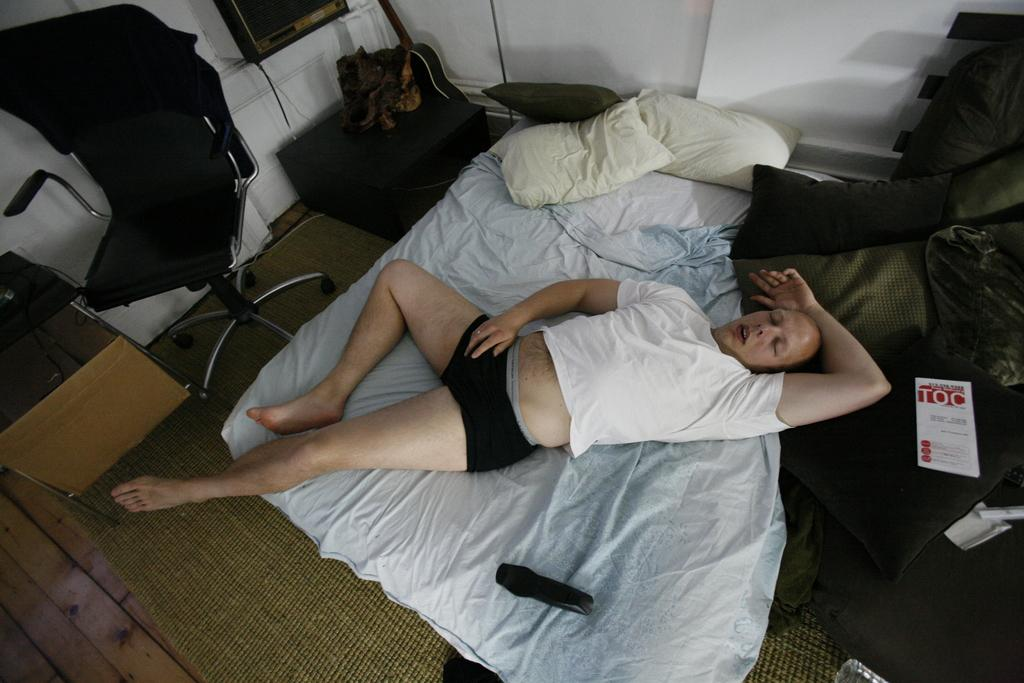What is the person in the image doing? There is a person sleeping on the bed in the image. What is on the bed besides the person? There are pillows on the bed. What can be seen in the background of the image? There is a wall, a chair, and a television in the background of the image. How many giraffes can be seen in the image? There are no giraffes present in the image. What type of earthquake is happening in the image? There is no earthquake depicted in the image. 